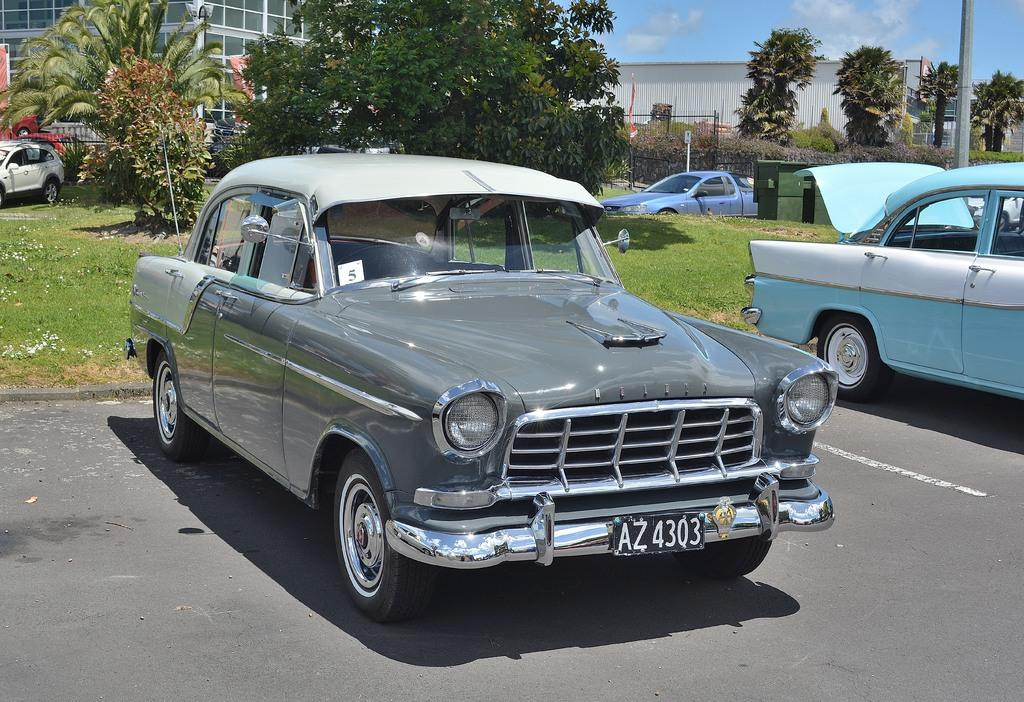What type of vehicles can be seen in the image? There are cars in the image. What type of vegetation is present in the image? There are trees and grass in the image. What type of barrier is visible in the image? There is a fence in the image. What object can be seen in the image? There is an object in the image, but its specific nature is not mentioned in the facts. What is on the right side of the image? There is a pole on the right side of the image. What structures can be seen in the background of the image? There are buildings in the background of the image. What part of the natural environment is visible in the image? The sky is visible in the background of the image. What type of bear can be seen interacting with the object in the image? There is no bear present in the image; it only features cars, trees, grass, a fence, an object, a pole, buildings, and the sky. What type of government is responsible for the maintenance of the buildings in the image? The facts provided do not give any information about the government or its role in the maintenance of the buildings in the image. 